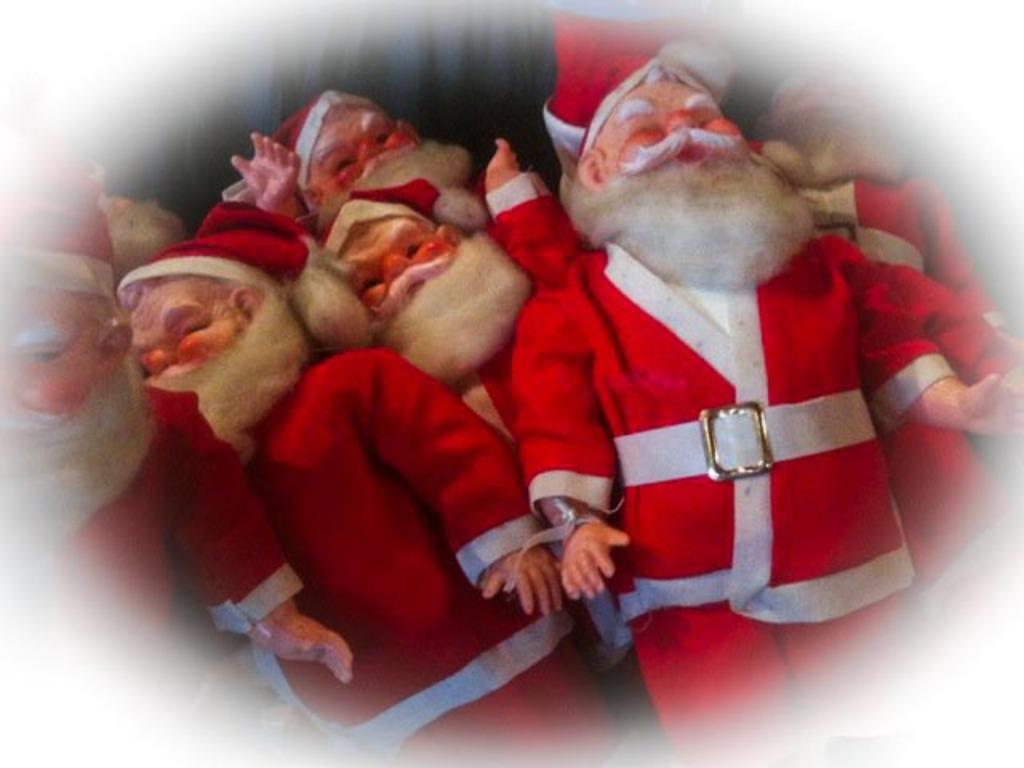What type of toys are present in the image? There are toy Santa Clauses in the image. What colors are the dresses of the toy Santa Clauses? The toy Santa Clauses are wearing white and red color dresses. What language are the toy Santa Clauses speaking in the image? There is no indication in the image that the toy Santa Clauses are speaking any language. 